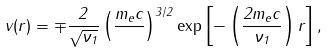<formula> <loc_0><loc_0><loc_500><loc_500>v ( r ) = \mp \frac { 2 } { \sqrt { \nu _ { 1 } } } \left ( \frac { m _ { e } c } { } \right ) ^ { 3 / 2 } \exp \left [ - \left ( \frac { 2 m _ { e } c } { \nu _ { 1 } } \right ) r \right ] ,</formula> 